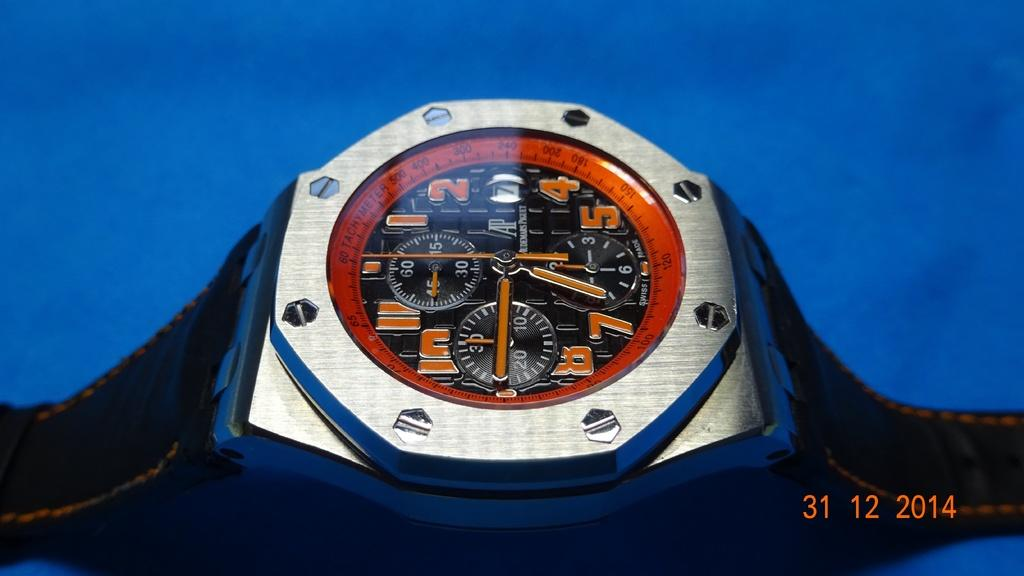<image>
Offer a succinct explanation of the picture presented. A watch face features orange numbers, such as 1, 2, 4, and 5. 